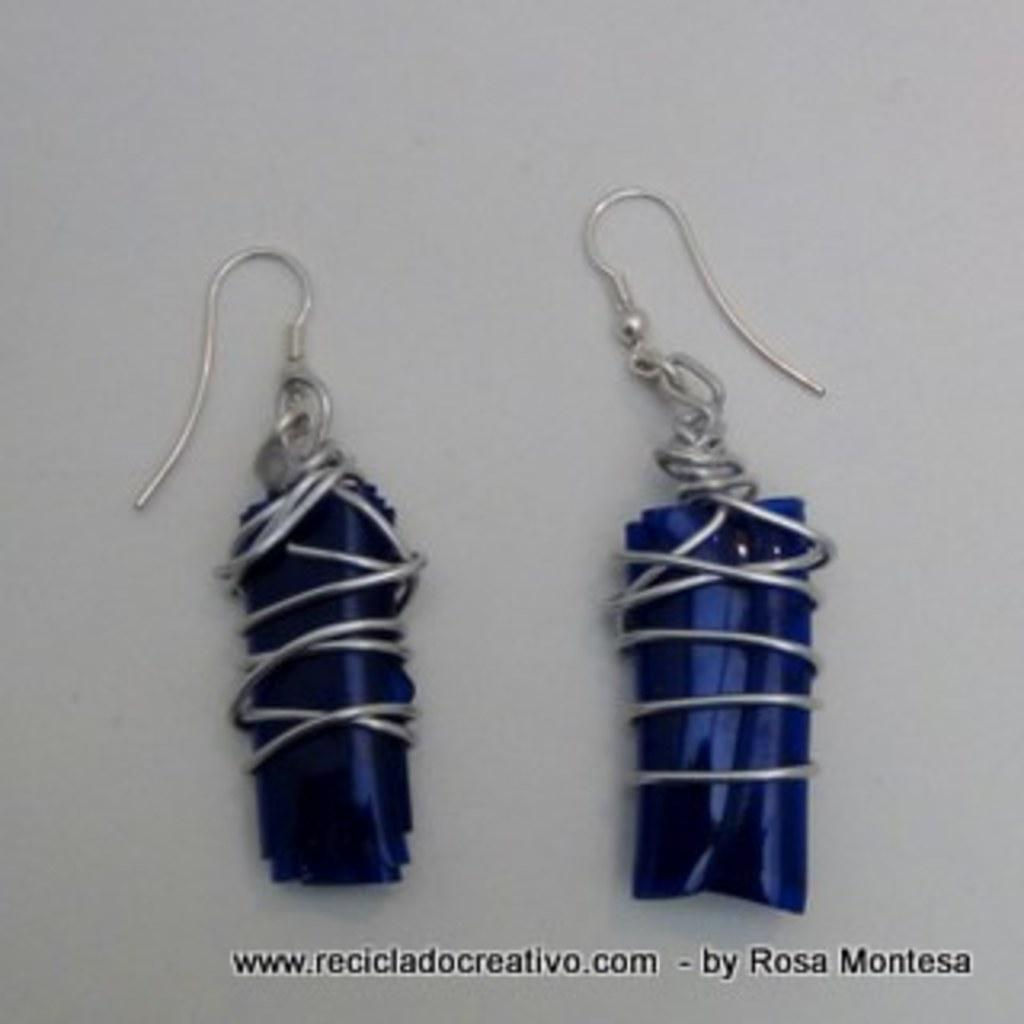What type of accessory is featured in the image? There is a pair of earrings in the image. What color are the earrings? The earrings are blue in color. What color is the background of the image? The background of the image is white. How many boats are visible in the image? There are no boats present in the image; it features a pair of blue earrings against a white background. What type of advice can be seen written on the earrings in the image? There is no advice written on the earrings in the image; they are simply blue earrings against a white background. 